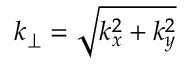Convert formula to latex. <formula><loc_0><loc_0><loc_500><loc_500>k _ { \perp } = \sqrt { k _ { x } ^ { 2 } + k _ { y } ^ { 2 } }</formula> 